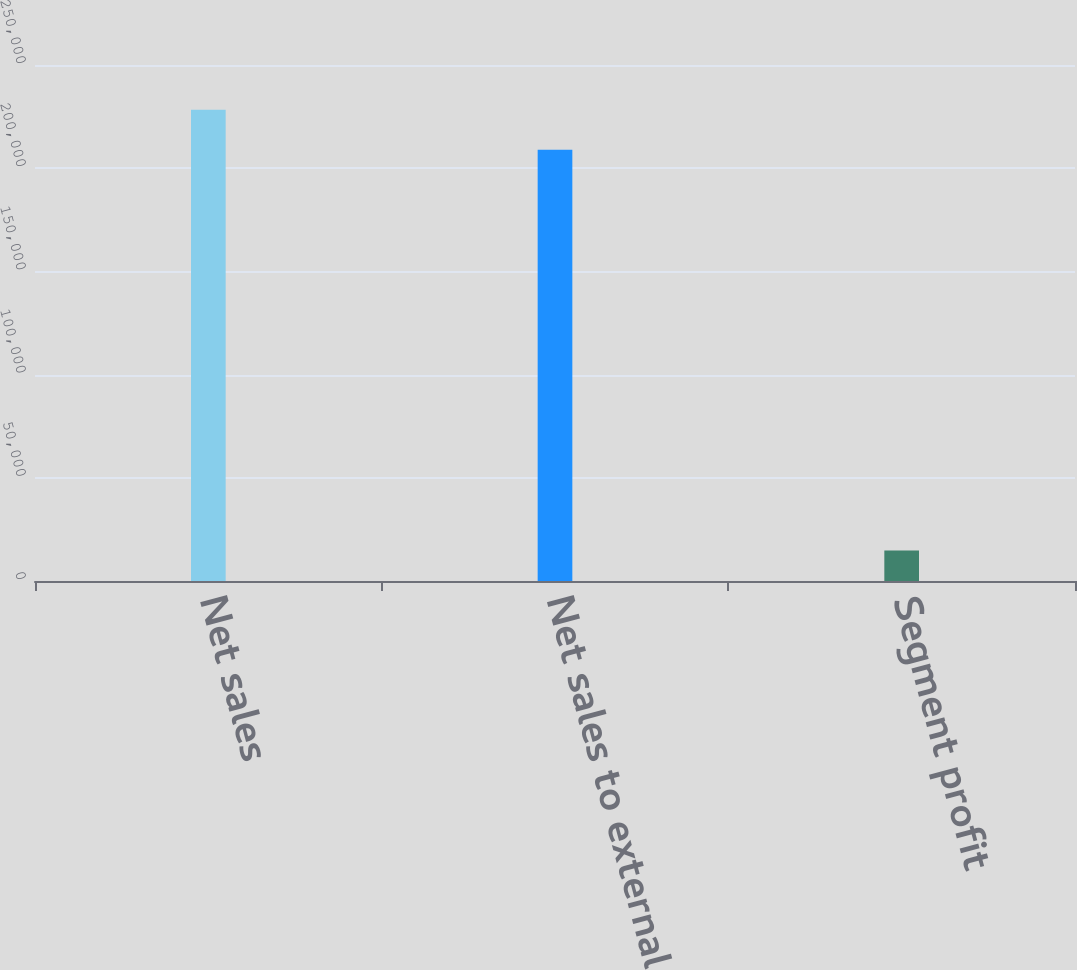<chart> <loc_0><loc_0><loc_500><loc_500><bar_chart><fcel>Net sales<fcel>Net sales to external<fcel>Segment profit<nl><fcel>228366<fcel>208895<fcel>14745<nl></chart> 